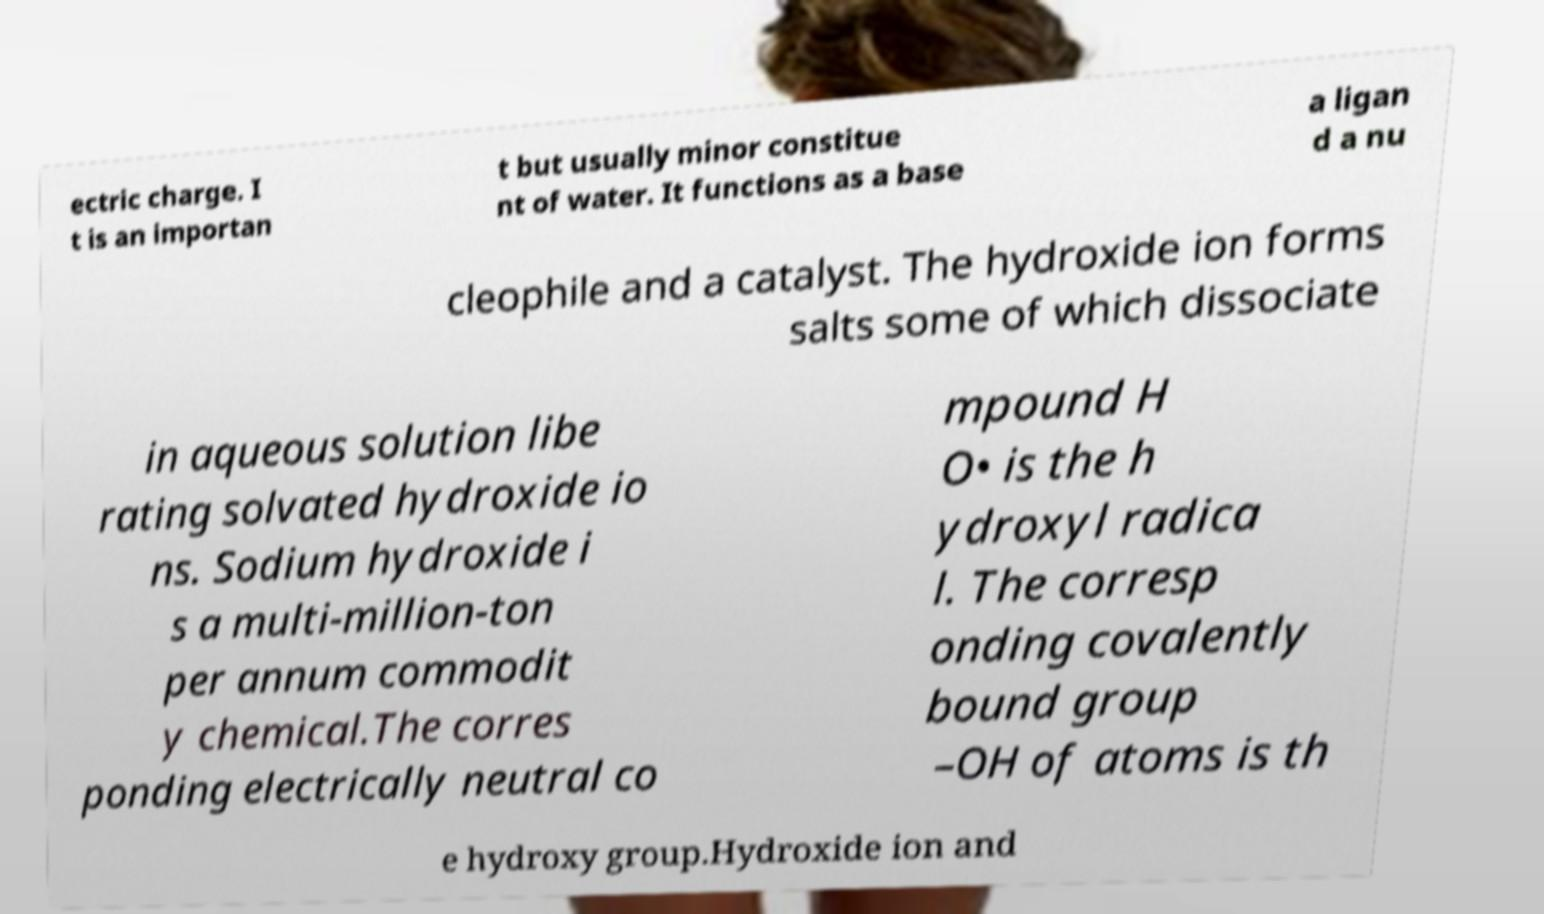Can you read and provide the text displayed in the image?This photo seems to have some interesting text. Can you extract and type it out for me? ectric charge. I t is an importan t but usually minor constitue nt of water. It functions as a base a ligan d a nu cleophile and a catalyst. The hydroxide ion forms salts some of which dissociate in aqueous solution libe rating solvated hydroxide io ns. Sodium hydroxide i s a multi-million-ton per annum commodit y chemical.The corres ponding electrically neutral co mpound H O• is the h ydroxyl radica l. The corresp onding covalently bound group –OH of atoms is th e hydroxy group.Hydroxide ion and 